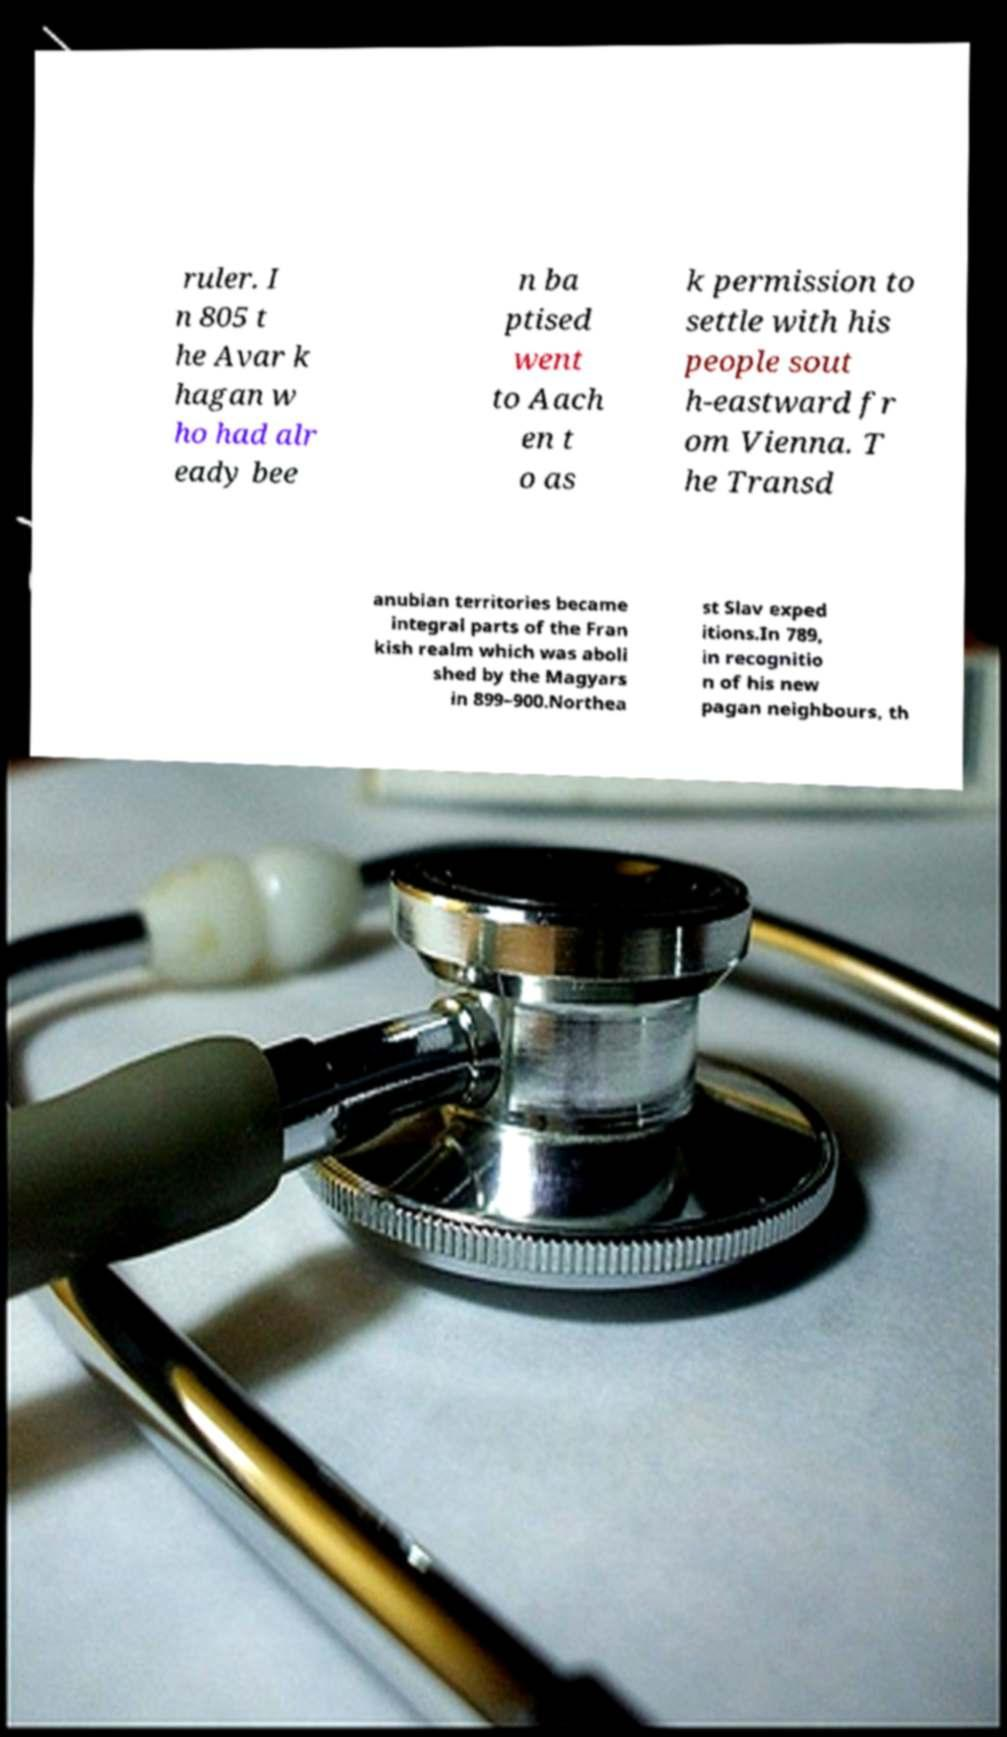For documentation purposes, I need the text within this image transcribed. Could you provide that? ruler. I n 805 t he Avar k hagan w ho had alr eady bee n ba ptised went to Aach en t o as k permission to settle with his people sout h-eastward fr om Vienna. T he Transd anubian territories became integral parts of the Fran kish realm which was aboli shed by the Magyars in 899–900.Northea st Slav exped itions.In 789, in recognitio n of his new pagan neighbours, th 